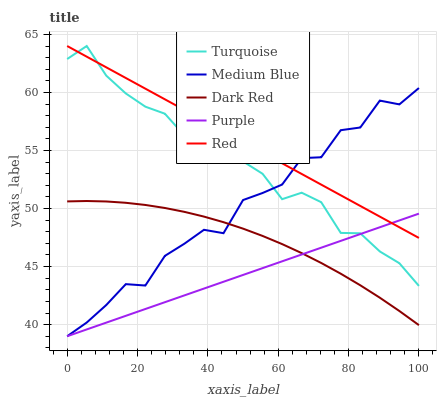Does Purple have the minimum area under the curve?
Answer yes or no. Yes. Does Dark Red have the minimum area under the curve?
Answer yes or no. No. Does Dark Red have the maximum area under the curve?
Answer yes or no. No. Is Medium Blue the roughest?
Answer yes or no. Yes. Is Dark Red the smoothest?
Answer yes or no. No. Is Dark Red the roughest?
Answer yes or no. No. Does Dark Red have the lowest value?
Answer yes or no. No. Does Dark Red have the highest value?
Answer yes or no. No. Is Dark Red less than Turquoise?
Answer yes or no. Yes. Is Turquoise greater than Dark Red?
Answer yes or no. Yes. Does Dark Red intersect Turquoise?
Answer yes or no. No. 